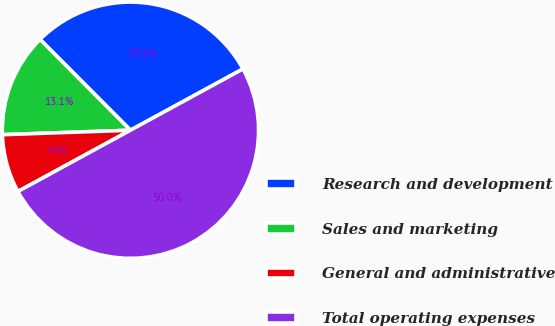Convert chart to OTSL. <chart><loc_0><loc_0><loc_500><loc_500><pie_chart><fcel>Research and development<fcel>Sales and marketing<fcel>General and administrative<fcel>Total operating expenses<nl><fcel>29.53%<fcel>13.09%<fcel>7.38%<fcel>50.0%<nl></chart> 